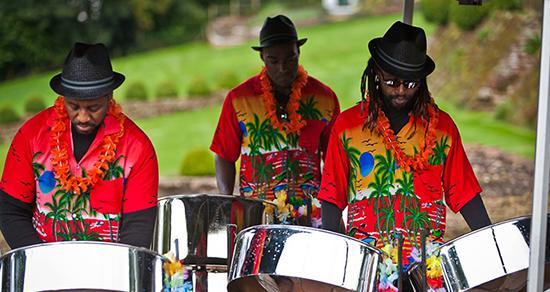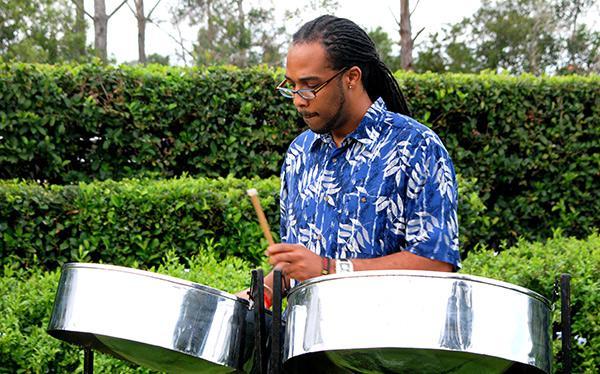The first image is the image on the left, the second image is the image on the right. Considering the images on both sides, is "One man with long braids wearing a blue hawaiian shirt is playing stainless steel bowl-shaped drums in the right image." valid? Answer yes or no. Yes. The first image is the image on the left, the second image is the image on the right. Evaluate the accuracy of this statement regarding the images: "The drummer in the image on the right is wearing a blue and white shirt.". Is it true? Answer yes or no. Yes. 